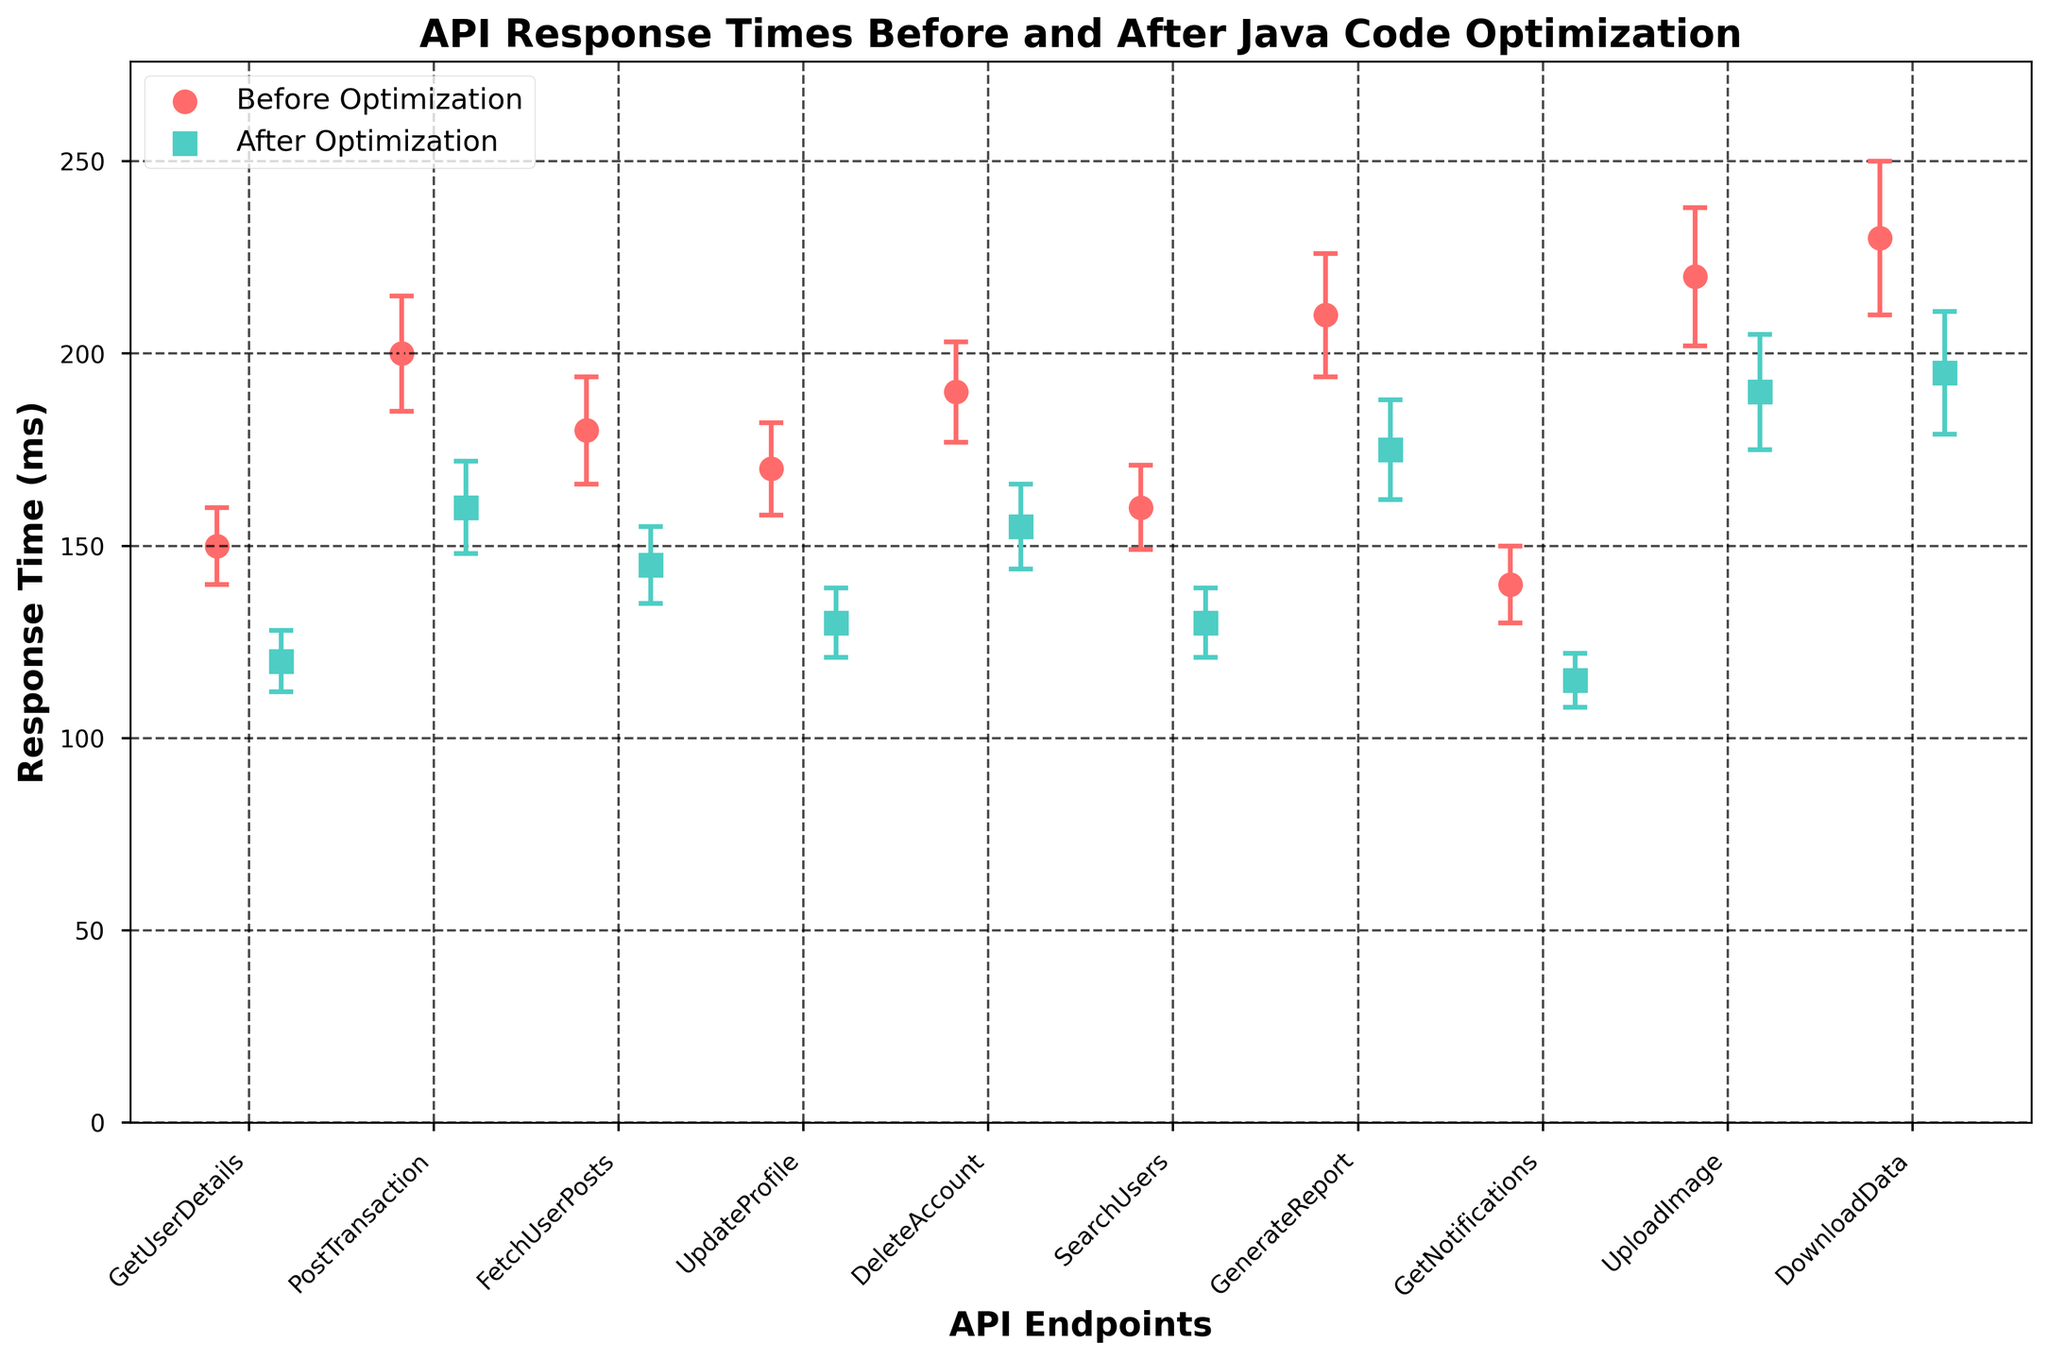How many API endpoints are shown in the figure? Count the distinct points plotted along the x-axis. Each point represents a different API endpoint.
Answer: 10 What are the colors used to represent the response times before and after optimization, respectively? Observe the color of the scatter plot markers in the legend. One color represents before optimization and the other after optimization.
Answer: Red and Teal Which API endpoint has the highest response time after optimization? Identify the highest value on the y-axis for the teal-colored markers and refer to the corresponding x-axis label.
Answer: DownloadData What is the difference in the response time before and after optimization for the 'PostTransaction' endpoint? Look at the response time before and after optimization for 'PostTransaction' and calculate the difference: 200 ms (before) - 160 ms (after) = 40 ms.
Answer: 40 ms How did the response time change for the 'GenerateReport' endpoint after optimization? Compare the response time before and after optimization for 'GenerateReport': 210 ms (before) vs. 175 ms (after).
Answer: Decreased by 35 ms What is the average response time before optimization across all endpoints? Add all the response times before optimization and divide by the number of endpoints. (150 + 200 + 180 + 170 + 190 + 160 + 210 + 140 + 220 + 230) / 10 = 185 ms.
Answer: 185 ms Which endpoint has the smallest standard deviation before optimization? Identify the smallest error bar (standard deviation) among the red points on the y-axis.
Answer: GetUserDetails What is the largest reduction in response time after optimization for any endpoint? Calculate the reduction for each endpoint and find the largest one. Example: UploadImage: 220 ms - 190 ms = 30 ms, largest reduction is for GenerateReport: 210 ms - 175 ms = 35 ms.
Answer: 35 ms Which API endpoint has the narrowest error bar after optimization? Observe the error bars (y-err) for the teal-colored points and determine the one with the smallest range.
Answer: GetNotifications 